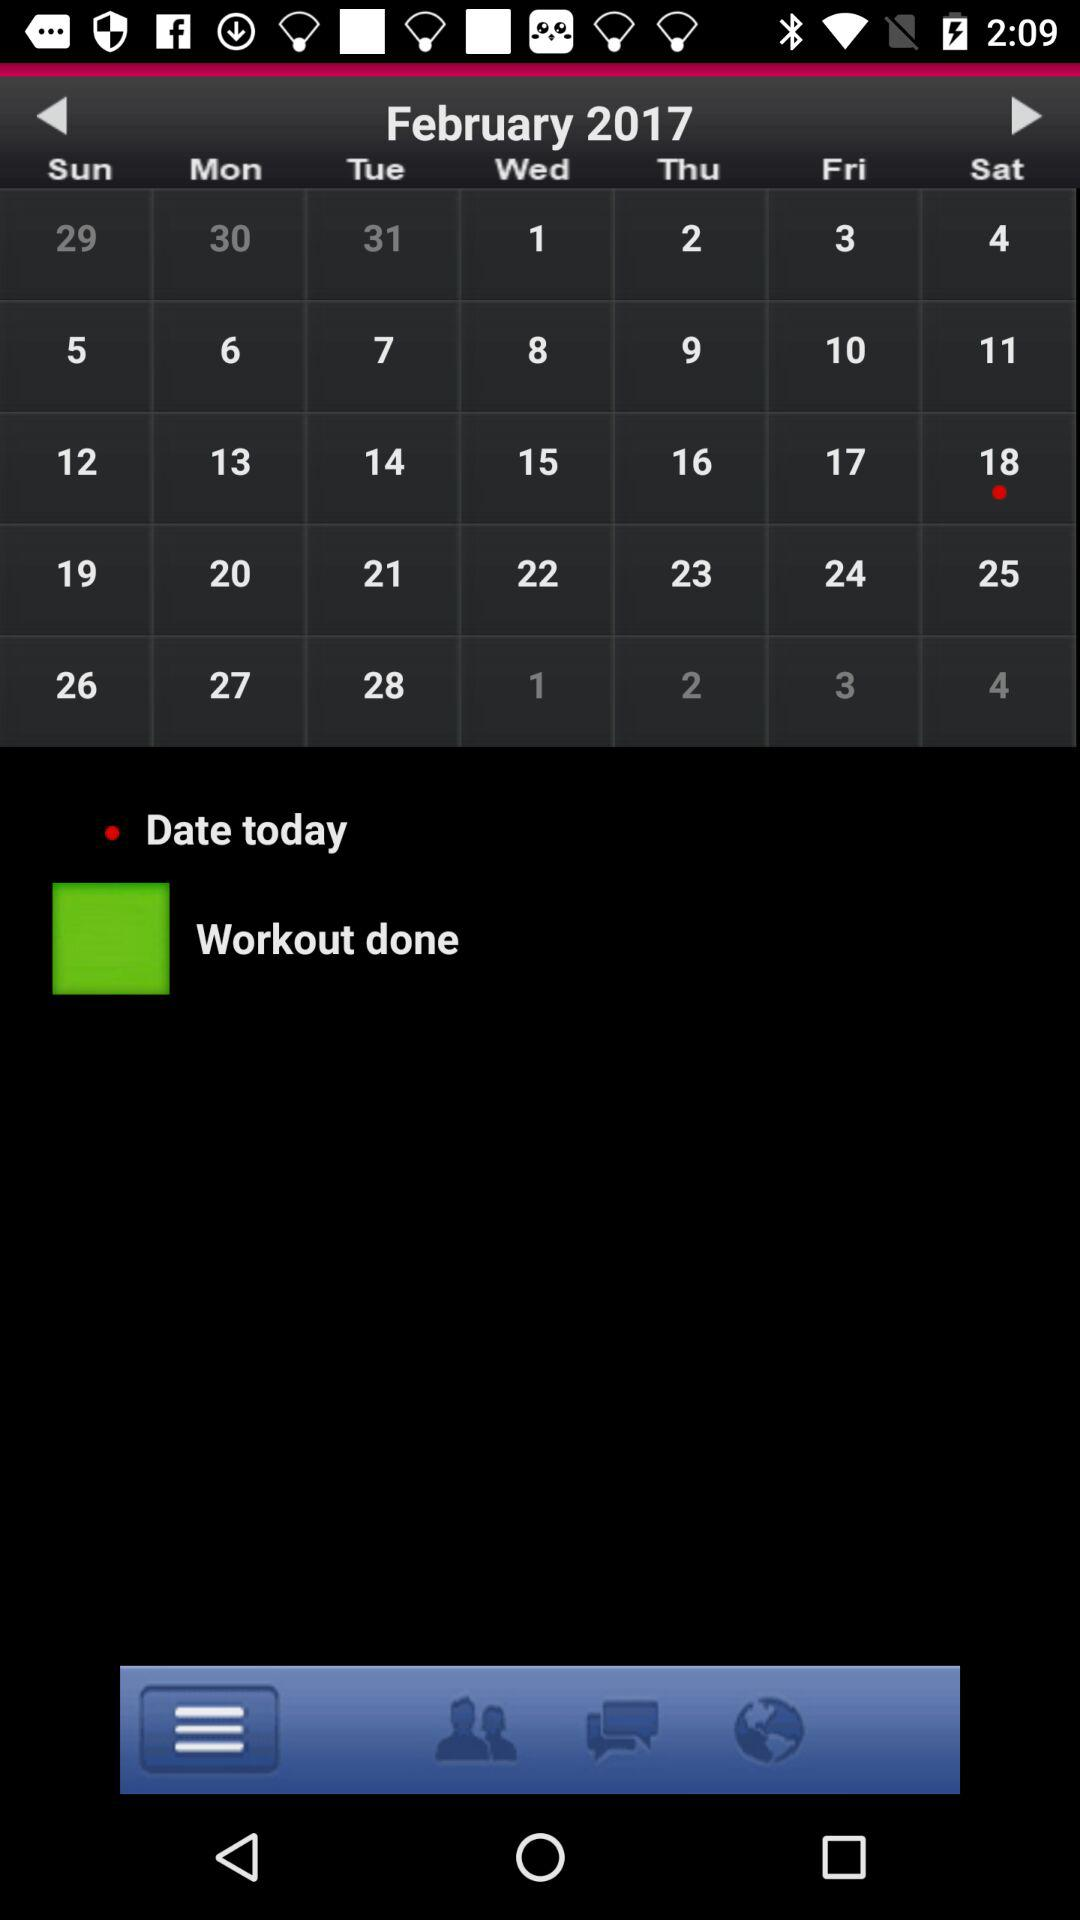What is the date today? The date is Saturday, February 18, 2017. 